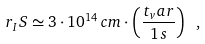<formula> <loc_0><loc_0><loc_500><loc_500>r _ { I } S \simeq 3 \cdot 1 0 ^ { 1 4 } \, c m \cdot \left ( \frac { t _ { v } a r } { 1 \, s } \right ) \ ,</formula> 